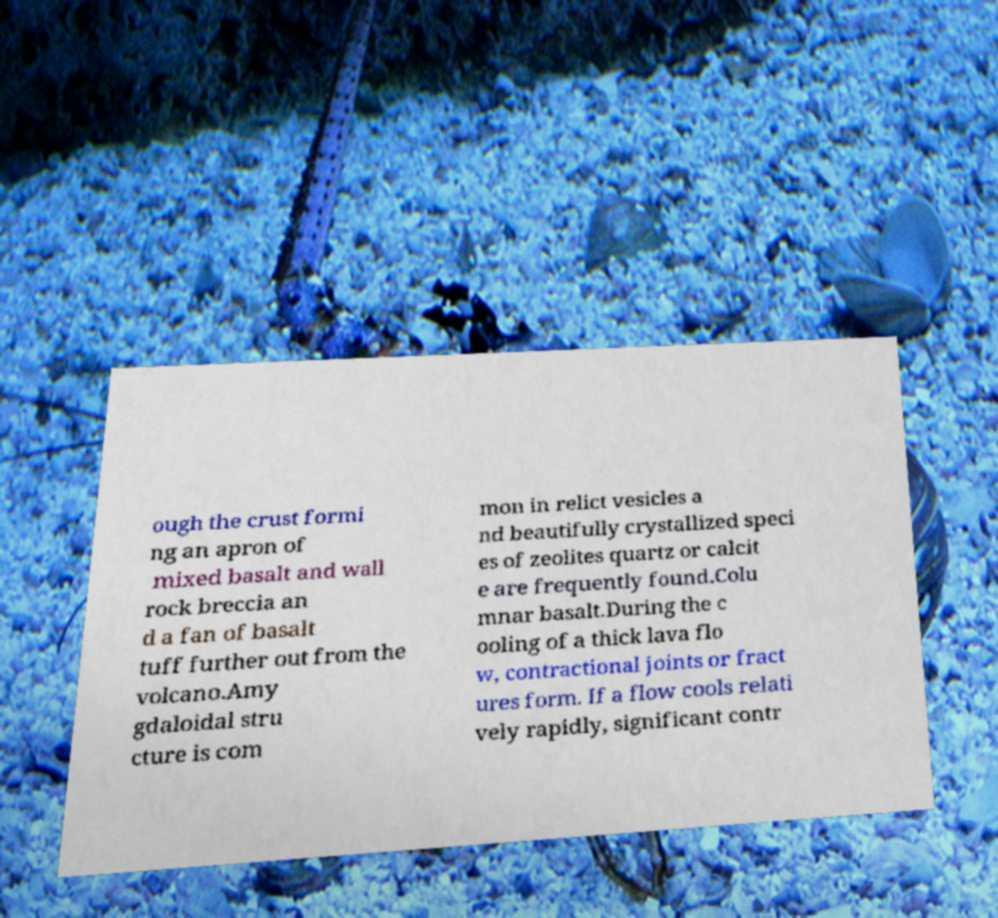Could you assist in decoding the text presented in this image and type it out clearly? ough the crust formi ng an apron of mixed basalt and wall rock breccia an d a fan of basalt tuff further out from the volcano.Amy gdaloidal stru cture is com mon in relict vesicles a nd beautifully crystallized speci es of zeolites quartz or calcit e are frequently found.Colu mnar basalt.During the c ooling of a thick lava flo w, contractional joints or fract ures form. If a flow cools relati vely rapidly, significant contr 